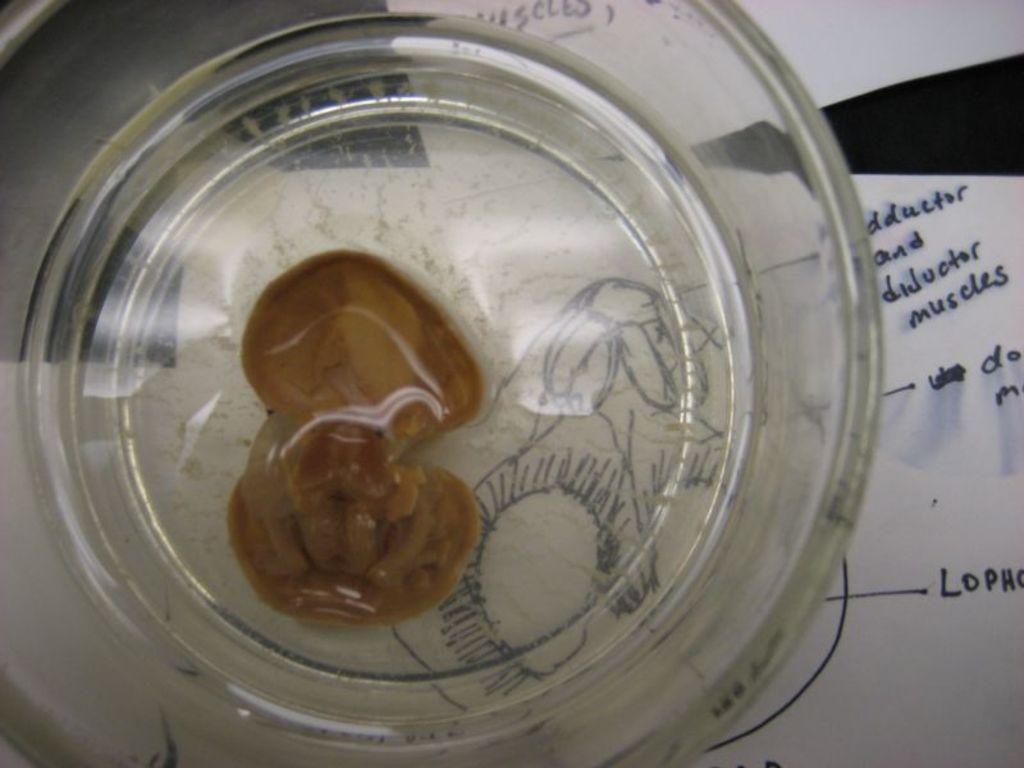Please provide a concise description of this image. In this image, It looks like a shell, which is in a glass. In the background, I can see the papers, which are on a table. 